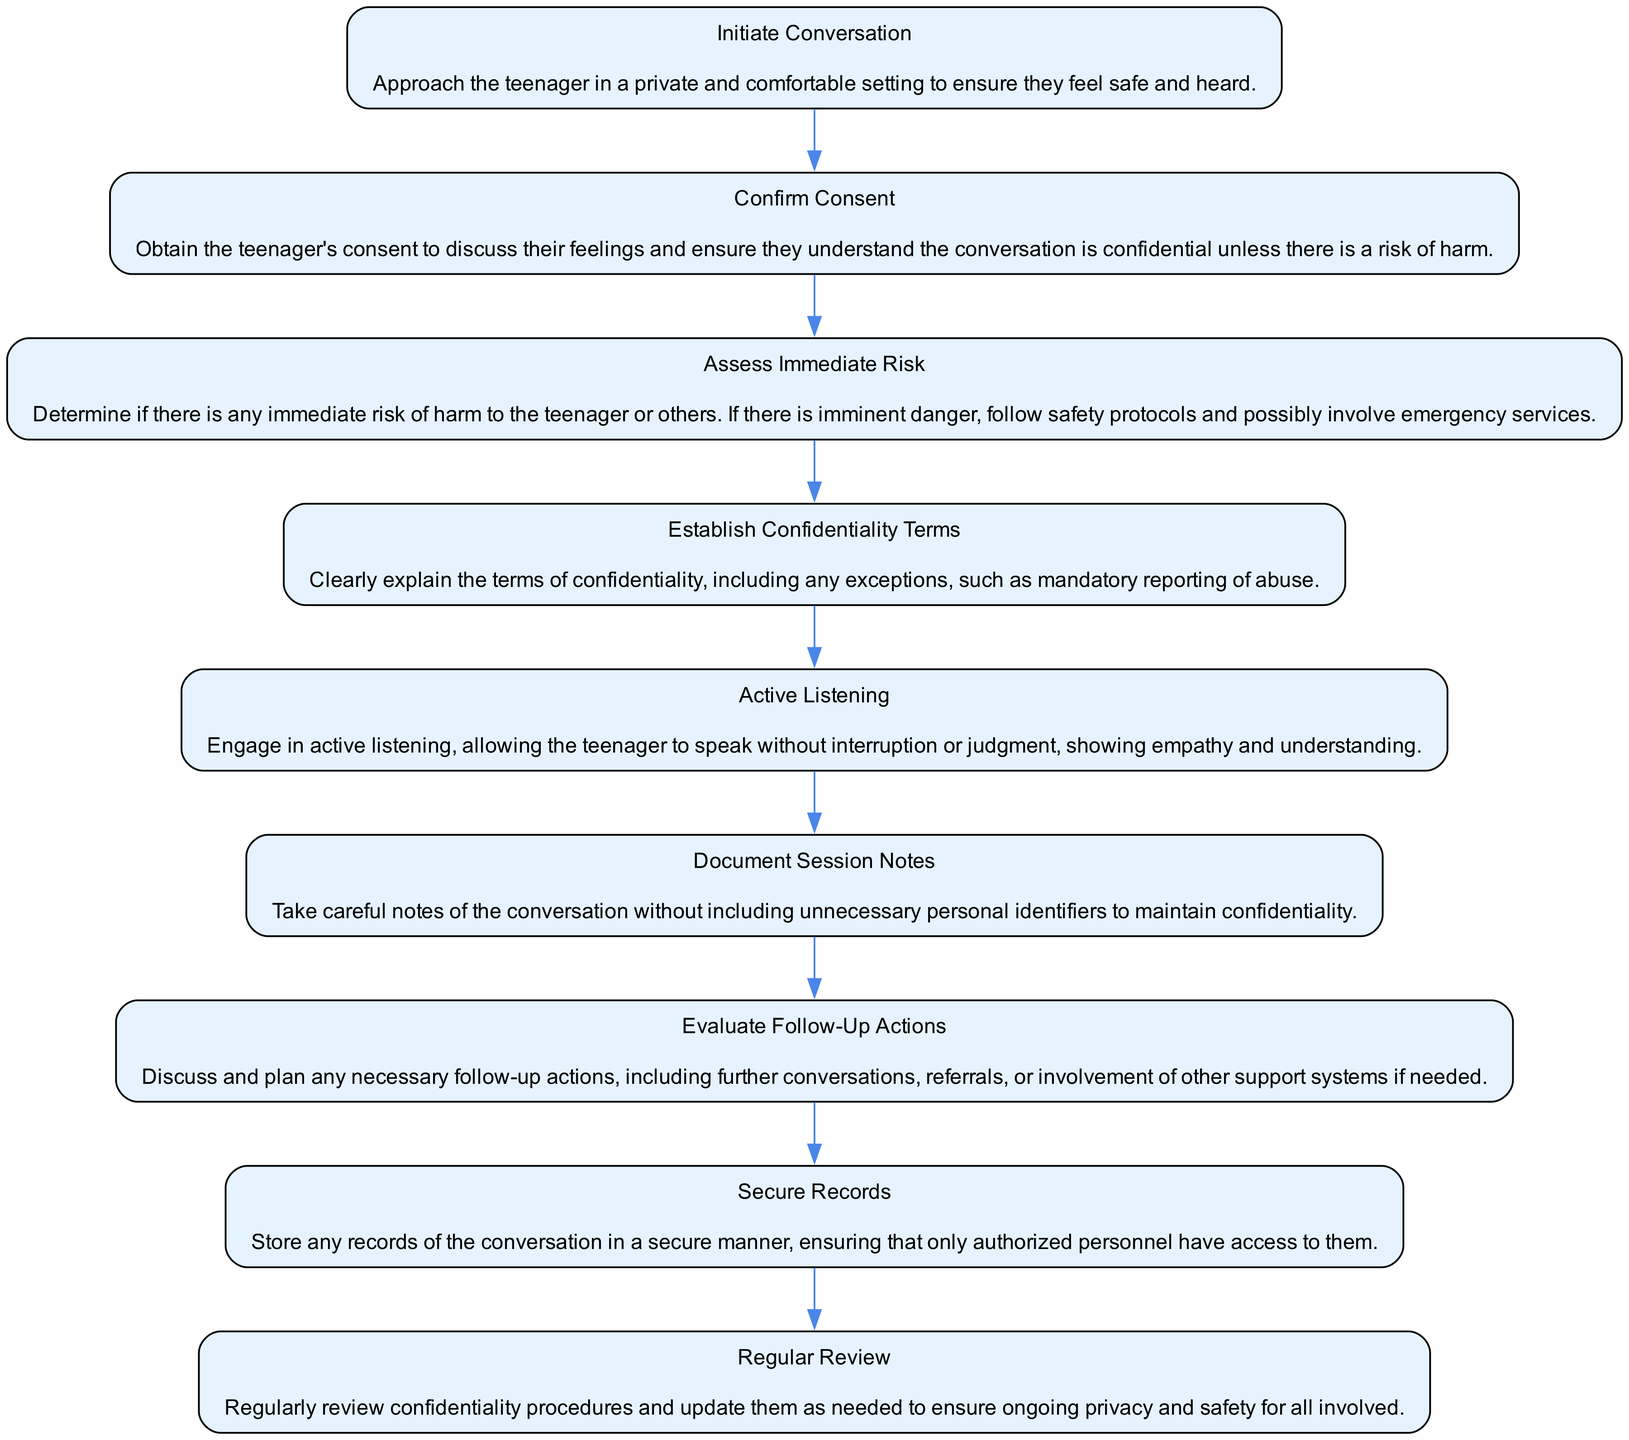What is the first step in the process? The first step listed in the diagram is "Initiate Conversation," which is about approaching the teenager in a private setting.
Answer: Initiate Conversation How many total steps are there in the diagram? The diagram lists 9 distinct steps in the process of managing confidential conversations.
Answer: 9 What step follows "Confirm Consent"? After "Confirm Consent," the next step is "Assess Immediate Risk," which involves determining any risk of harm.
Answer: Assess Immediate Risk What is explained in the "Establish Confidentiality Terms" step? This step describes the importance of clearly explaining the terms of confidentiality, including exceptions.
Answer: Terms of confidentiality What is the last step in the process? The last step indicated in the diagram is "Regular Review," where confidentiality procedures are reviewed and updated regularly.
Answer: Regular Review What should be done if there is an immediate risk of harm? If there is an immediate risk of harm, the procedure indicates to follow safety protocols and possibly involve emergency services.
Answer: Follow safety protocols What is the purpose of the "Active Listening" step? The "Active Listening" step emphasizes engaging with the teenager without interruption and showing empathy during the conversation.
Answer: Engage with empathy Which step involves securely storing records? The step that involves securely storing records is "Secure Records," ensuring only authorized personnel have access.
Answer: Secure Records What happens if there is no immediate risk during the "Assess Immediate Risk" step? If there is no immediate risk during the "Assess Immediate Risk" step, the flow would continue to "Establish Confidentiality Terms."
Answer: Continue to Establish Confidentiality Terms 